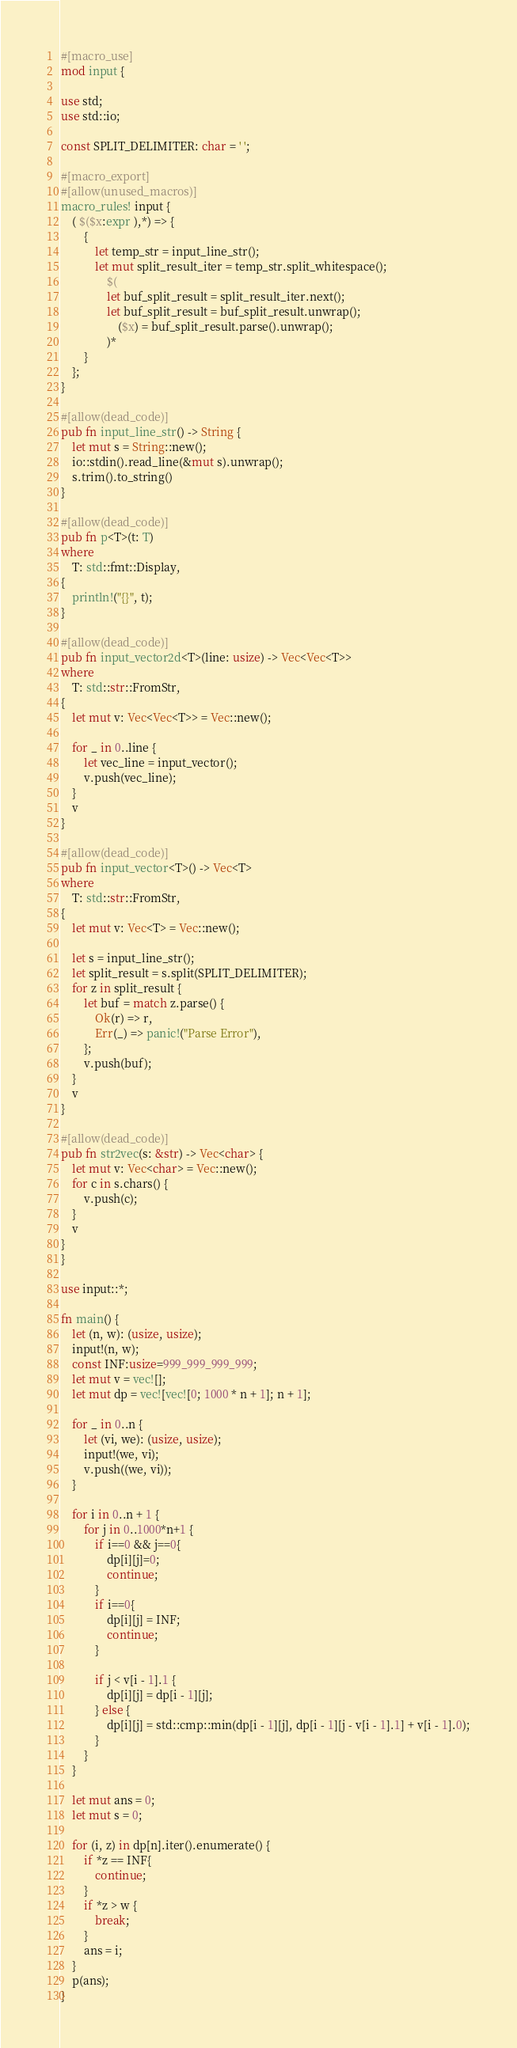Convert code to text. <code><loc_0><loc_0><loc_500><loc_500><_Rust_>#[macro_use]
mod input {

use std;
use std::io;

const SPLIT_DELIMITER: char = ' ';

#[macro_export]
#[allow(unused_macros)]
macro_rules! input {
    ( $($x:expr ),*) => {
        {
            let temp_str = input_line_str();
            let mut split_result_iter = temp_str.split_whitespace();
                $(
                let buf_split_result = split_result_iter.next();
                let buf_split_result = buf_split_result.unwrap();
                    ($x) = buf_split_result.parse().unwrap();
                )*
        }
    };
}

#[allow(dead_code)]
pub fn input_line_str() -> String {
    let mut s = String::new();
    io::stdin().read_line(&mut s).unwrap();
    s.trim().to_string()
}

#[allow(dead_code)]
pub fn p<T>(t: T)
where
    T: std::fmt::Display,
{
    println!("{}", t);
}

#[allow(dead_code)]
pub fn input_vector2d<T>(line: usize) -> Vec<Vec<T>>
where
    T: std::str::FromStr,
{
    let mut v: Vec<Vec<T>> = Vec::new();

    for _ in 0..line {
        let vec_line = input_vector();
        v.push(vec_line);
    }
    v
}

#[allow(dead_code)]
pub fn input_vector<T>() -> Vec<T>
where
    T: std::str::FromStr,
{
    let mut v: Vec<T> = Vec::new();

    let s = input_line_str();
    let split_result = s.split(SPLIT_DELIMITER);
    for z in split_result {
        let buf = match z.parse() {
            Ok(r) => r,
            Err(_) => panic!("Parse Error"),
        };
        v.push(buf);
    }
    v
}

#[allow(dead_code)]
pub fn str2vec(s: &str) -> Vec<char> {
    let mut v: Vec<char> = Vec::new();
    for c in s.chars() {
        v.push(c);
    }
    v
}
}

use input::*;

fn main() {
    let (n, w): (usize, usize);
    input!(n, w);
    const INF:usize=999_999_999_999;
    let mut v = vec![];
    let mut dp = vec![vec![0; 1000 * n + 1]; n + 1];

    for _ in 0..n {
        let (vi, we): (usize, usize);
        input!(we, vi);
        v.push((we, vi));
    }

    for i in 0..n + 1 {
        for j in 0..1000*n+1 {
            if i==0 && j==0{
                dp[i][j]=0;
                continue;
            }
            if i==0{
                dp[i][j] = INF;
                continue;
            }

            if j < v[i - 1].1 {
                dp[i][j] = dp[i - 1][j];
            } else {
                dp[i][j] = std::cmp::min(dp[i - 1][j], dp[i - 1][j - v[i - 1].1] + v[i - 1].0);
            }
        }
    }

    let mut ans = 0;
    let mut s = 0;

    for (i, z) in dp[n].iter().enumerate() {
        if *z == INF{
            continue;
        }
        if *z > w {
            break;
        }
        ans = i;
    }
    p(ans);
}</code> 